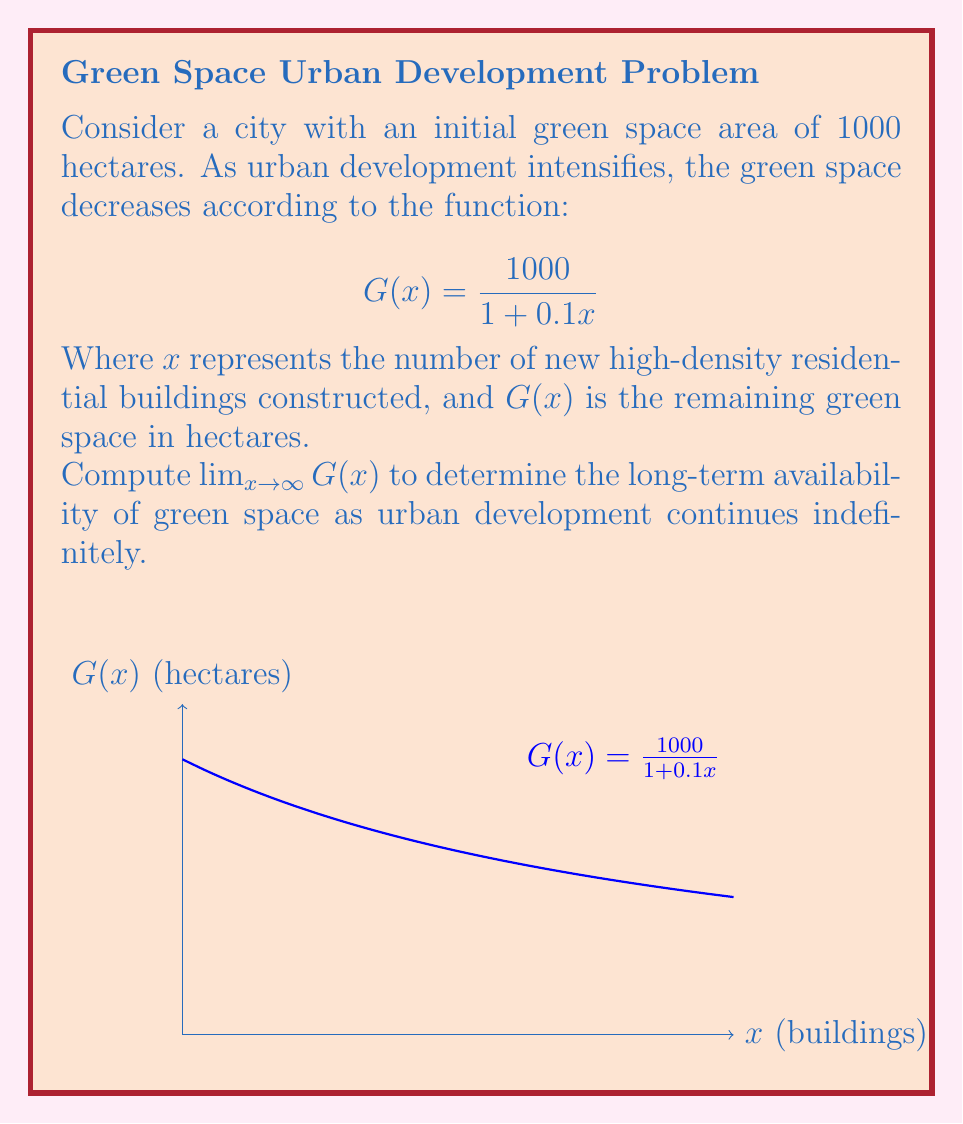Show me your answer to this math problem. To compute $\lim_{x \to \infty} G(x)$, we follow these steps:

1) First, let's examine the function:
   $$G(x) = \frac{1000}{1 + 0.1x}$$

2) As $x$ approaches infinity, the denominator $(1 + 0.1x)$ will grow infinitely large.

3) We can rewrite the function to better see what happens as $x$ approaches infinity:
   $$G(x) = \frac{1000}{1 + 0.1x} = \frac{1000/0.1x}{(1/0.1x) + 1} = \frac{10000/x}{10/x + 1}$$

4) Now, as $x$ approaches infinity:
   $\lim_{x \to \infty} \frac{10000/x}{10/x + 1} = \frac{0}{0 + 1} = 0$

5) This is because as $x$ gets very large, both $10000/x$ and $10/x$ approach 0.

Therefore, as urban development continues indefinitely (i.e., as $x$ approaches infinity), the available green space approaches 0 hectares.
Answer: $\lim_{x \to \infty} G(x) = 0$ hectares 